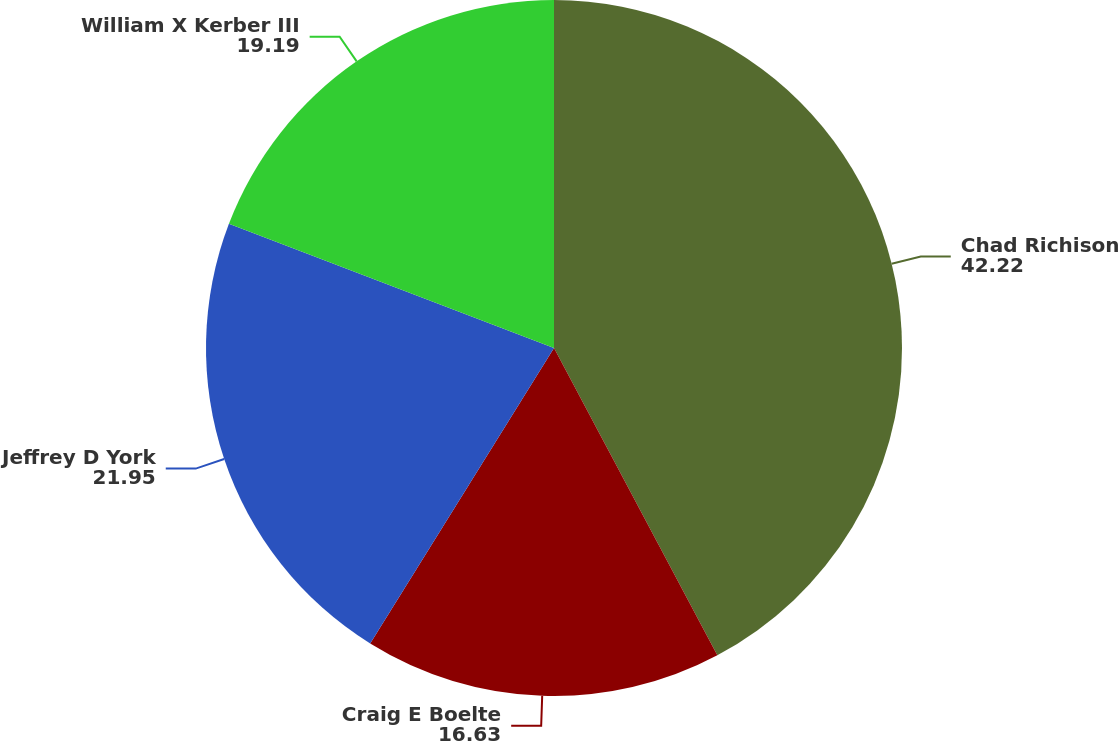Convert chart. <chart><loc_0><loc_0><loc_500><loc_500><pie_chart><fcel>Chad Richison<fcel>Craig E Boelte<fcel>Jeffrey D York<fcel>William X Kerber III<nl><fcel>42.22%<fcel>16.63%<fcel>21.95%<fcel>19.19%<nl></chart> 